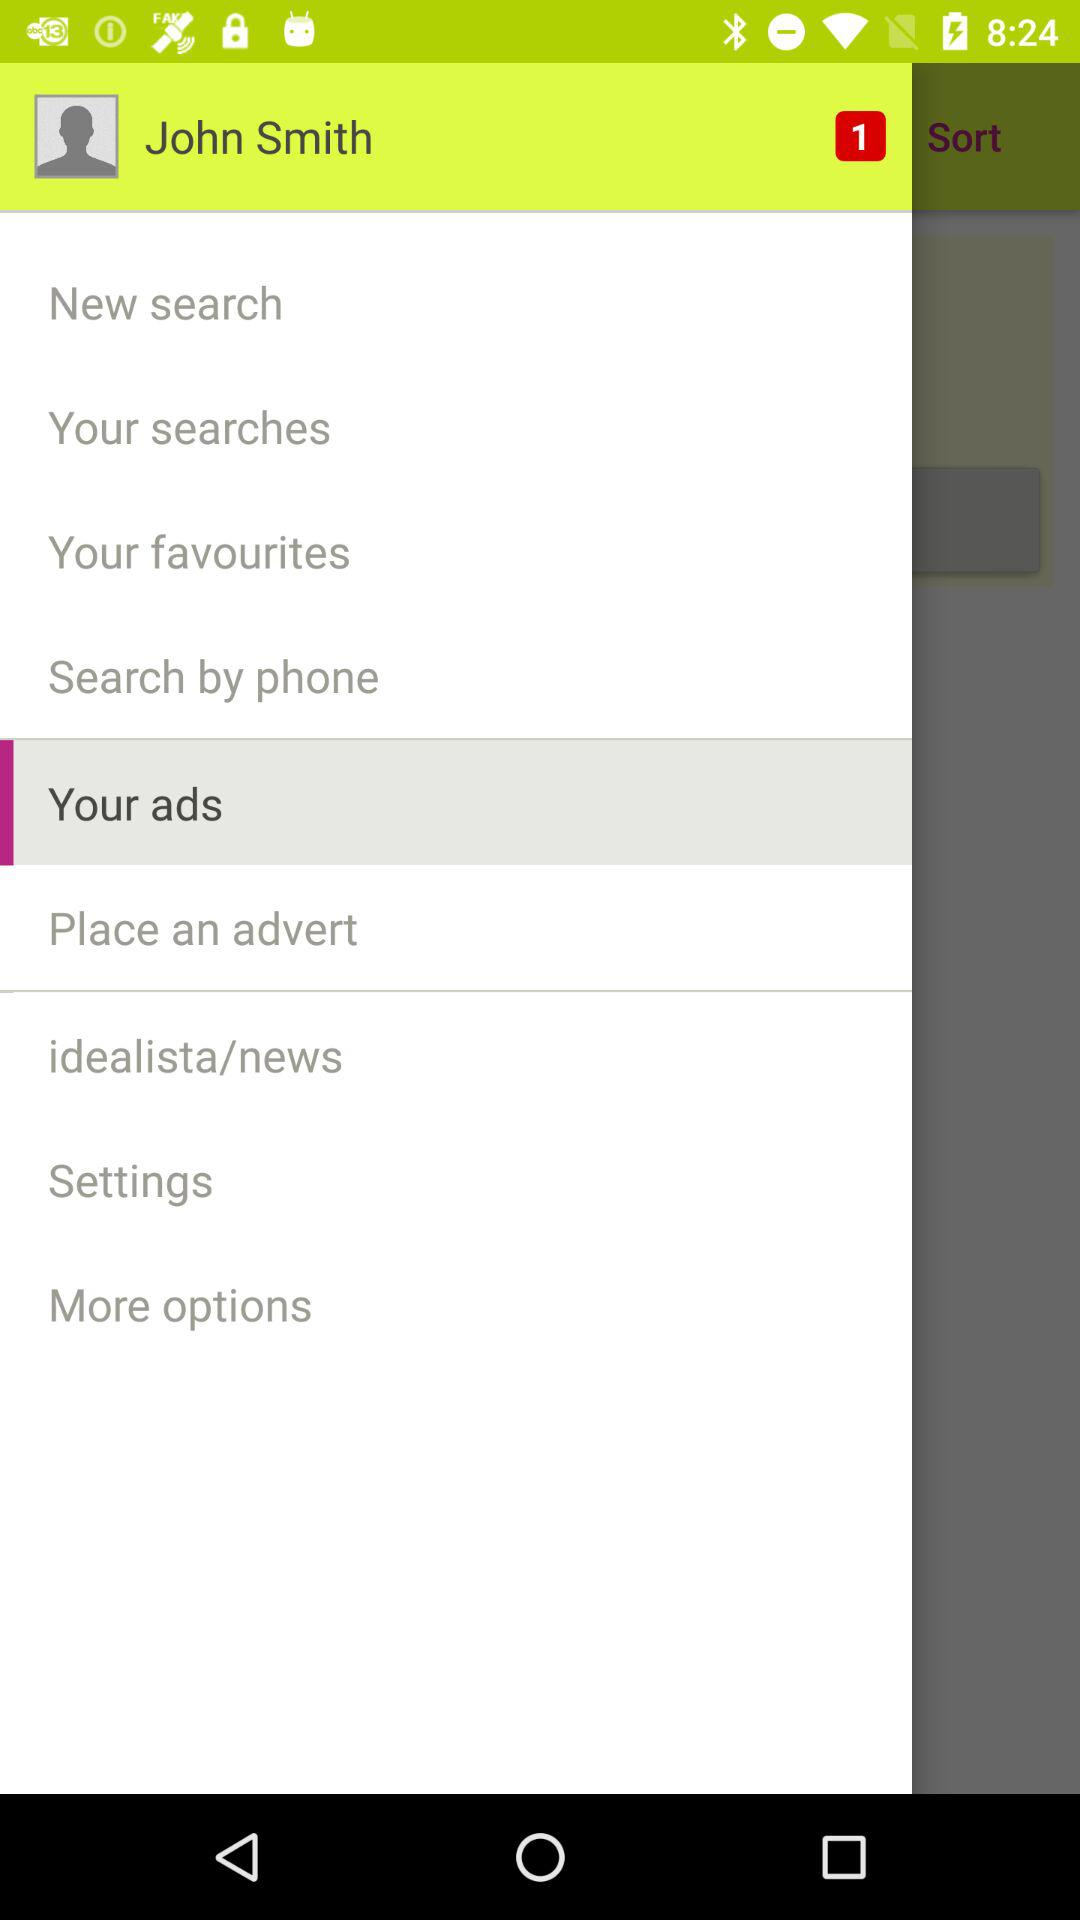How many unread notifications are there? There is one unread notification. 